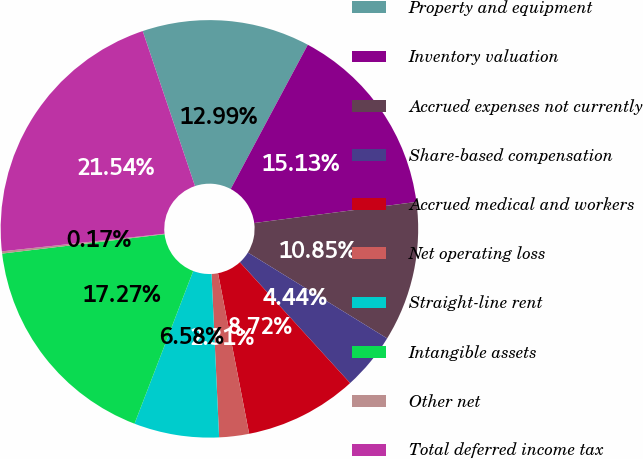Convert chart to OTSL. <chart><loc_0><loc_0><loc_500><loc_500><pie_chart><fcel>Property and equipment<fcel>Inventory valuation<fcel>Accrued expenses not currently<fcel>Share-based compensation<fcel>Accrued medical and workers<fcel>Net operating loss<fcel>Straight-line rent<fcel>Intangible assets<fcel>Other net<fcel>Total deferred income tax<nl><fcel>12.99%<fcel>15.13%<fcel>10.85%<fcel>4.44%<fcel>8.72%<fcel>2.31%<fcel>6.58%<fcel>17.27%<fcel>0.17%<fcel>21.54%<nl></chart> 